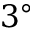<formula> <loc_0><loc_0><loc_500><loc_500>3 ^ { \circ }</formula> 